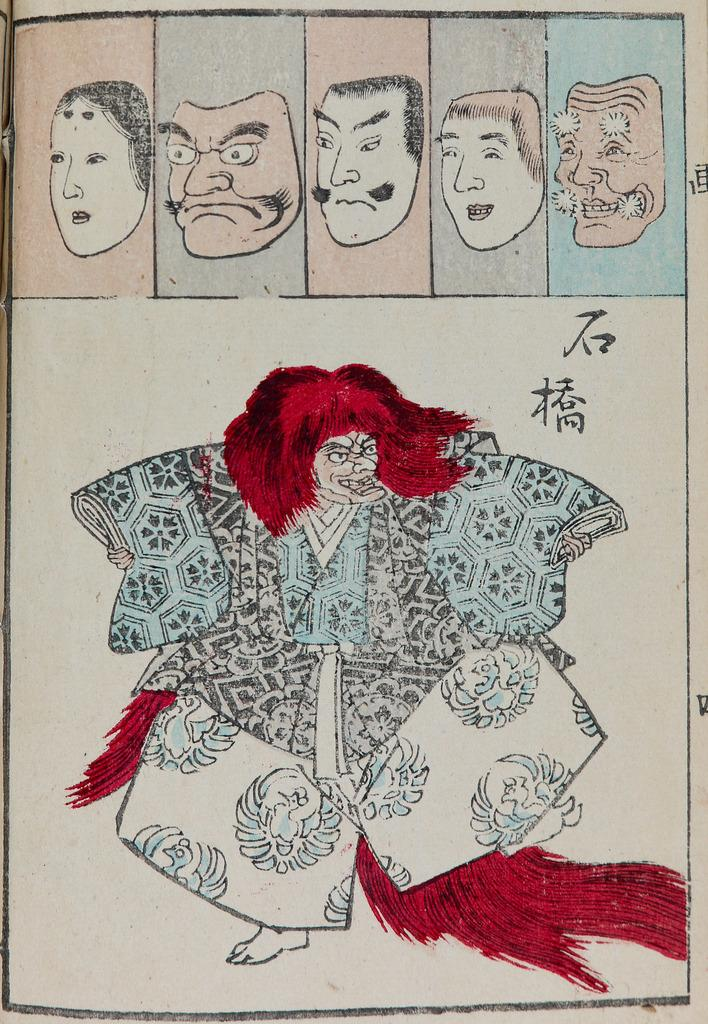What is present in the image that features visual content? There is a poster in the image. What can be found on the poster? There are pictures on the poster. Can you see a doll joining the insects in the pictures on the poster? There is no doll or insects present in the pictures on the poster; only other pictures can be seen. 